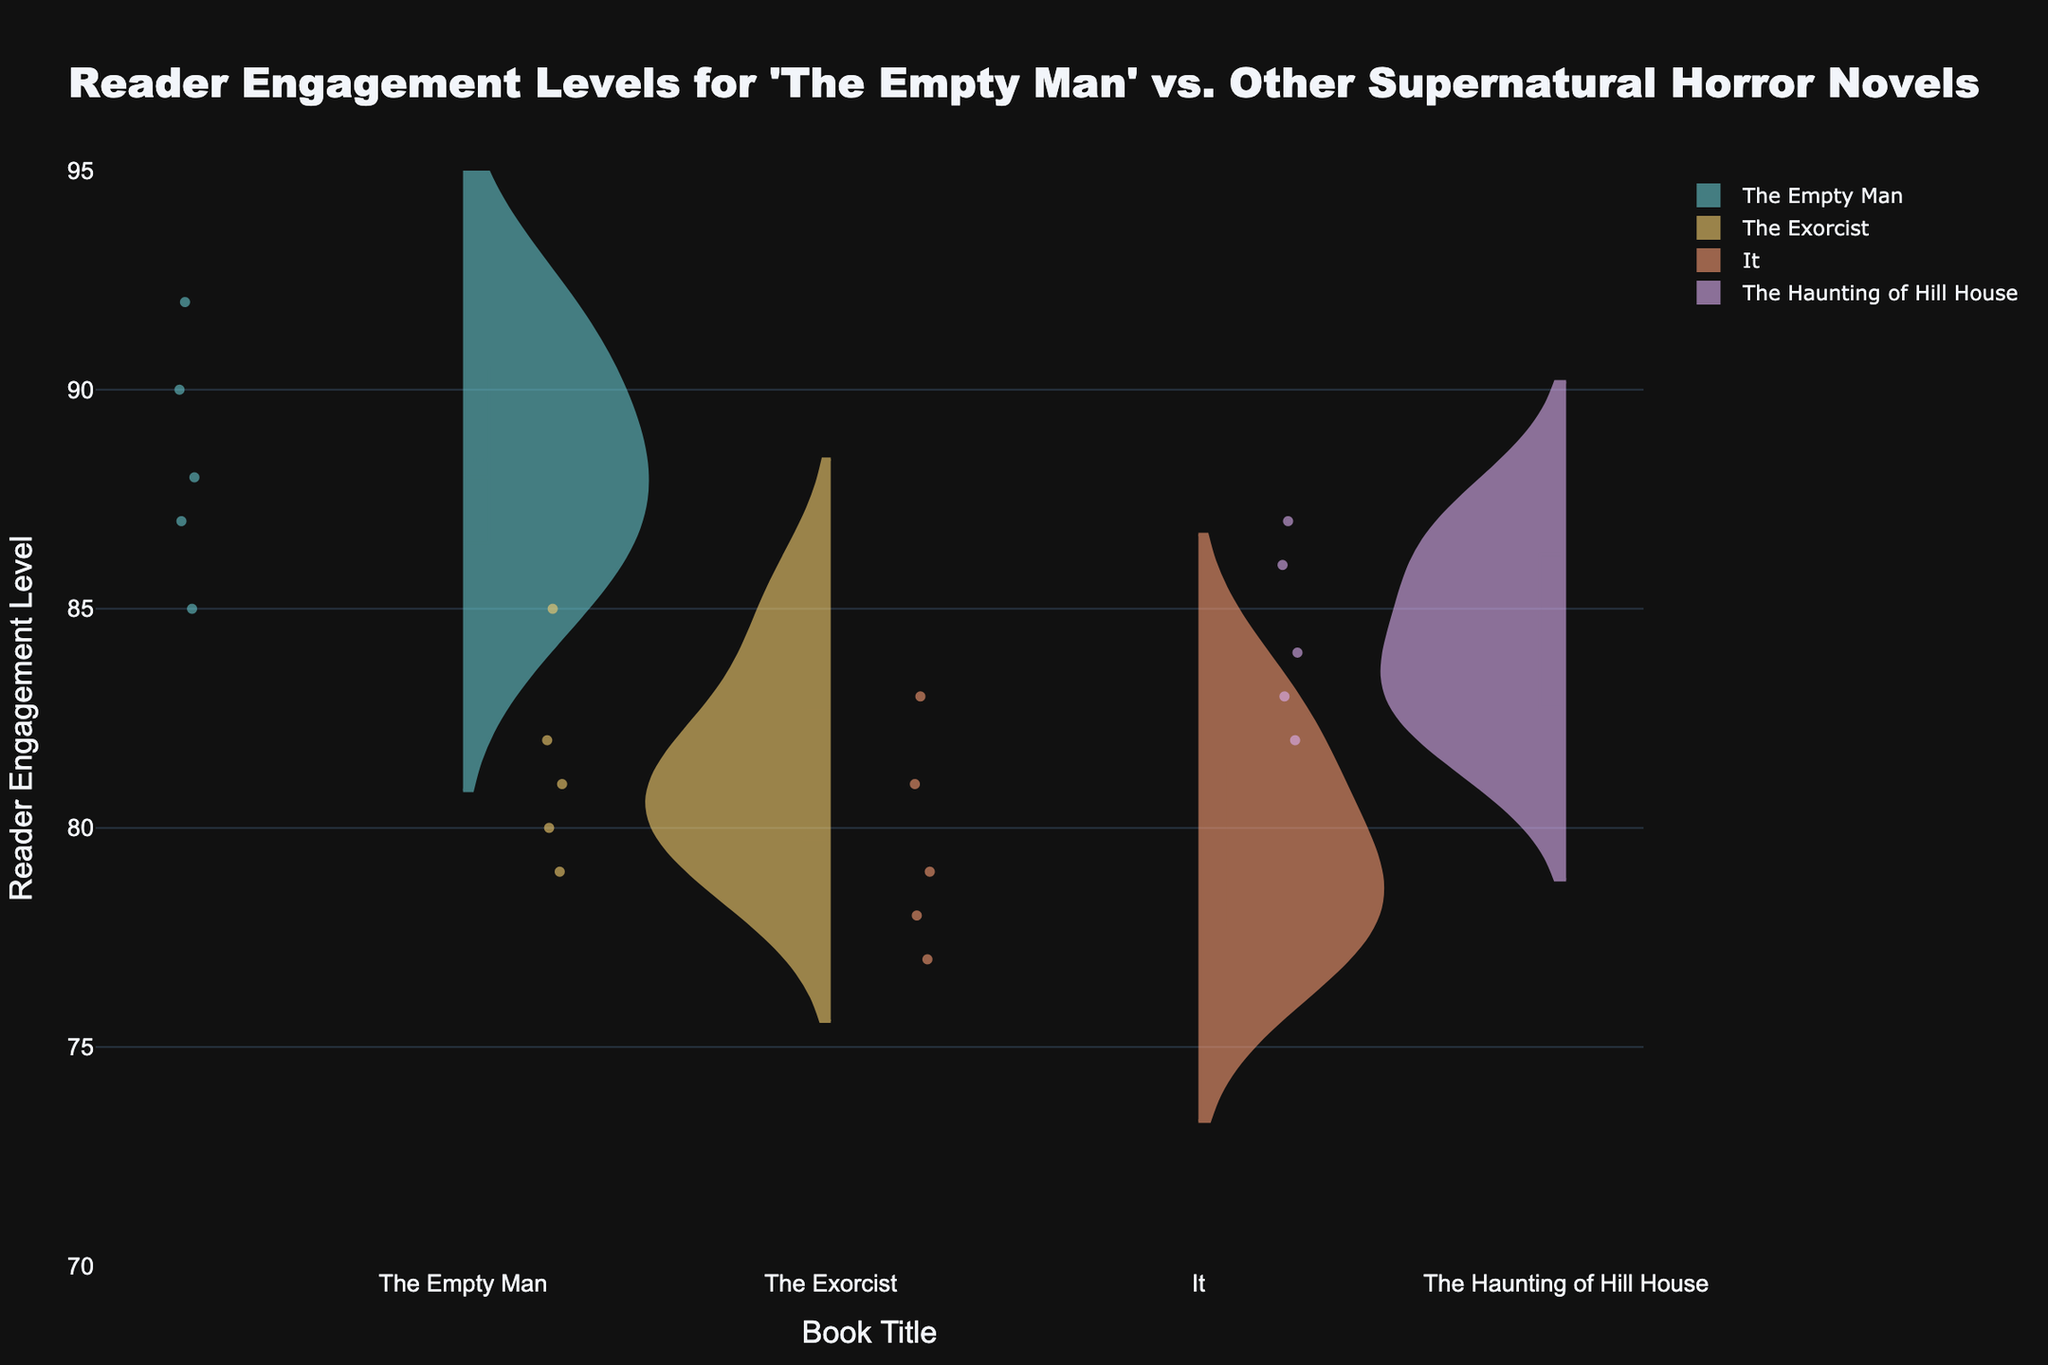How many book titles are compared in the figure? To determine how many book titles are compared, simply count the distinct book names represented in the figure.
Answer: 4 Which book has the highest engagement level? Identify the highest point on the y-axis for each violin plot and see which book's plot reaches the highest value.
Answer: The Empty Man What is the range of engagement levels for 'It'? Check the maximum and minimum engagement levels represented by the violin plot for 'It'. The range is the difference between these two points.
Answer: 78 to 83 Which book has the smallest spread in engagement levels? Observe the width and distribution of the violin plots. The book with the least spread will have the narrowest and most condensed plot.
Answer: The Haunting of Hill House Which book has the most uniform engagement levels? Look for the violin plot with the most even distribution and smallest variance in engagement levels.
Answer: The Empty Man How do the median engagement levels compare between 'The Exorcist' and 'The Empty Man'? Identify the horizontal line inside each violin plot, which represents the median. Compare the positions of these lines for 'The Exorcist' and 'The Empty Man'.
Answer: The Empty Man is higher What is the average engagement level for 'The Haunting of Hill House'? Add up the individual engagement levels for 'The Haunting of Hill House' and divide by the number of data points for that book.
Answer: 84.4 Is the engagement level for 'The Empty Man' more variable than 'It'? Compare the spread and variance of the engagement levels represented by the width and shape of the violin plots for 'The Empty Man' and 'It'.
Answer: No, 'It' has more variability Which book has readers with the lowest minimum engagement level? Identify the bottom-most point on the y-axis for each violin plot and determine which book has the lowest value.
Answer: It Are there any outliers in the engagement levels for 'The Exorcist'? Look for individual data points that deviate significantly from the rest of the distribution within the violin plot for 'The Exorcist'.
Answer: No 